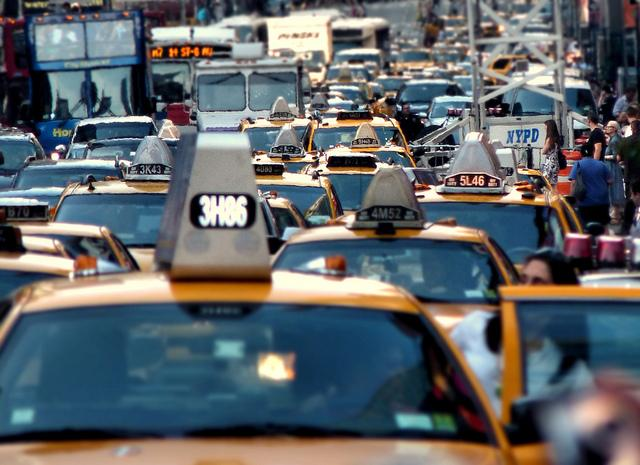What is happening on the road? Please explain your reasoning. traffic jam. The street is full of many cars and looks like rush hour traffic. 